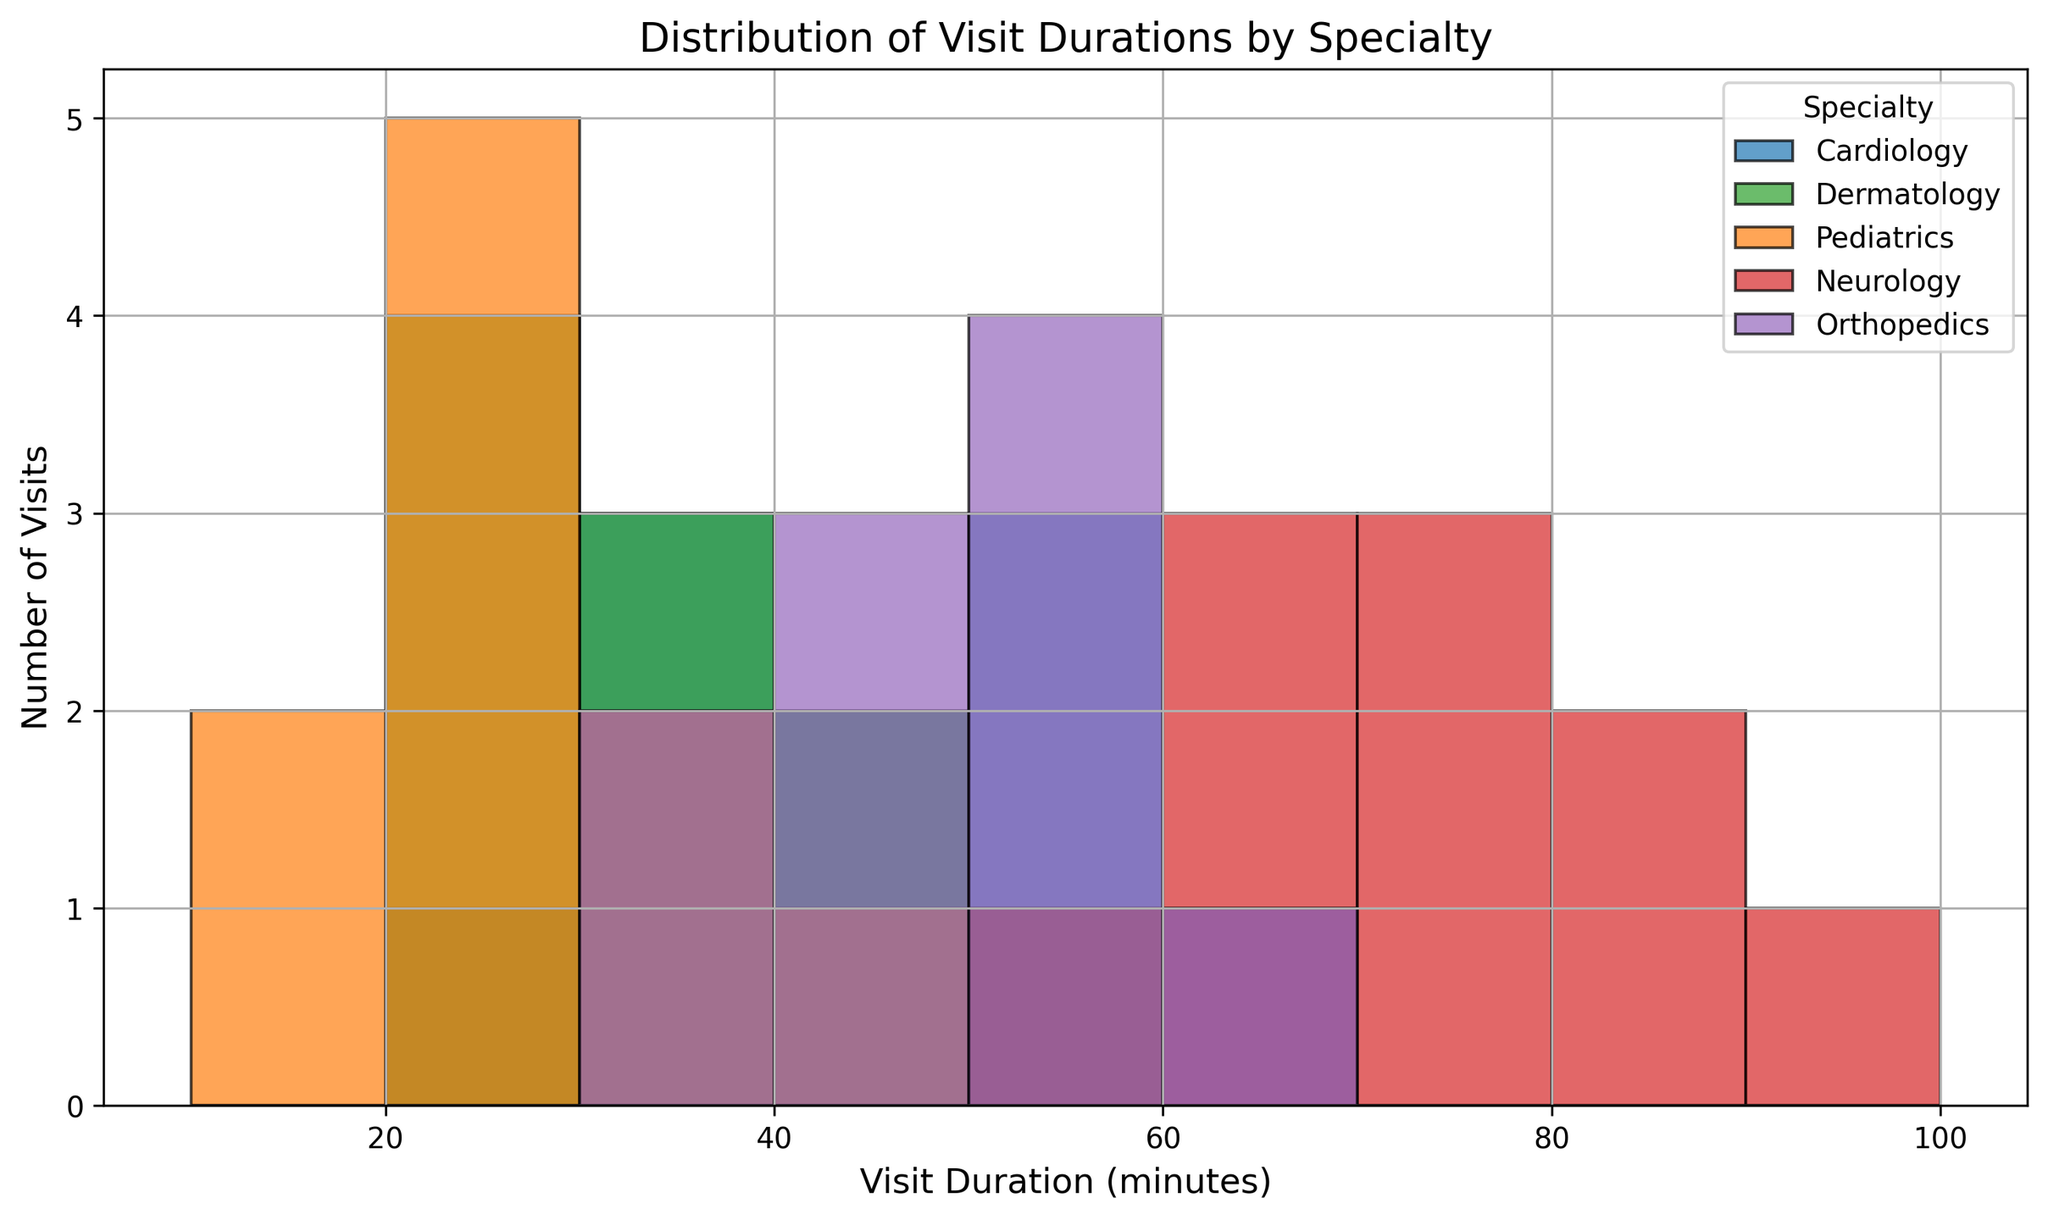What specialty has the highest frequency of visit durations between 50 and 60 minutes? From the figure, the height of the bars representing the number of visits in the 50-60 minutes range for each specialty needs to be compared. Cardiology, Orthopedics, and Neurology appear to have bars in this range. However, Neurology has the highest bar within this range.
Answer: Neurology Which specialty has the highest frequency of visit durations below 20 minutes? Visually, we need to find which specialty's bars are higher in the 10-20 minutes range. Both Dermatology and Pediatrics have visits under 20 minutes, but Pediatrics has the highest bar.
Answer: Pediatrics What is the range of visit durations for Dermatology? From the figure, observe the lowest and highest ranges of the histogram bins with Dermatology visits. They span from 20 to 50 minutes.
Answer: 20-50 How does the average visit duration for Cardiology compare to Pediatrics? Calculate the average visit duration for both. Cardiology's durations range mostly between 20 and 60 minutes, whereas Pediatrics ranges from 15 to 40 minutes. Cardiology has more significant bins in the higher duration ranges, suggesting a higher average.
Answer: Cardiology is higher Which specialty has the widest distribution of visit durations? The width can be determined by the range of bins with visit counts. Cardiologist visits are between 20 to 60, Dermatology between 20 to 50, Pediatrics 15 to 40, Neurology 55 to 90, and Orthopedics 30 to 60 minutes. Neurology has the widest spread.
Answer: Neurology Is the visit duration distribution for Orthopedics skewed towards longer or shorter durations? Look at the height of the bars. The bins lean towards the higher end of the duration scale (45 to 50 minutes are more frequent).
Answer: Longer durations How does the frequency of 30-minute visits compare across specialties? Identify the height of the bars corresponding to 30-minute durations. Cardiology has many 30-minute visits, followed by Pediatrics, Dermatology, and Orthopedics.
Answer: Cardiology > Pediatrics > Dermatology > Orthopedics What is the most frequent visit duration for Neurology? Look for the highest bar within Neurology. The highest frequency bar falls in the 60-minute bin.
Answer: 60 minutes What can you infer about the typical visit duration range for Cardiology? Examine the range of bins for Cardiology with visit frequencies. Cardiology spans from 20 to 60 minutes, indicating the typical duration lies within this range.
Answer: 20-60 minutes 